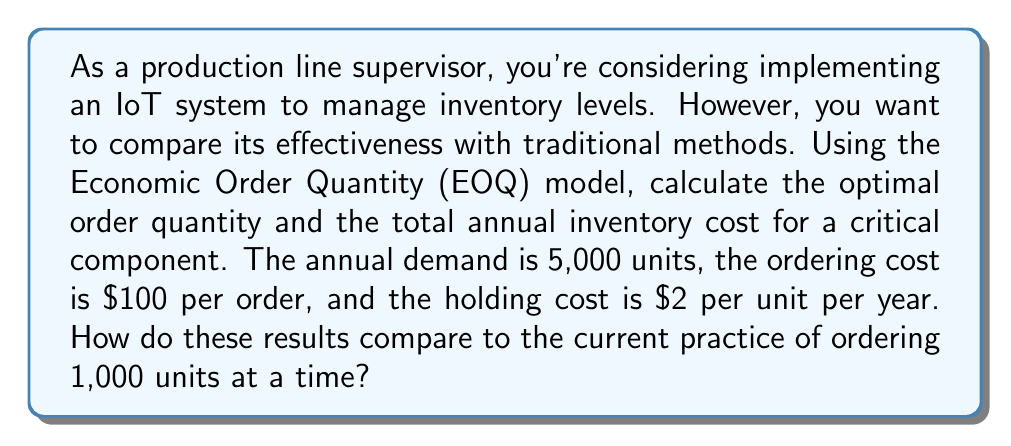Teach me how to tackle this problem. Let's approach this step-by-step using the EOQ model:

1. EOQ Formula:
   The Economic Order Quantity is given by:
   
   $$ Q^* = \sqrt{\frac{2DS}{H}} $$
   
   Where:
   $Q^*$ = Optimal order quantity
   $D$ = Annual demand
   $S$ = Ordering cost per order
   $H$ = Holding cost per unit per year

2. Given values:
   $D = 5,000$ units
   $S = \$100$ per order
   $H = \$2$ per unit per year

3. Calculate the EOQ:
   $$ Q^* = \sqrt{\frac{2 \cdot 5,000 \cdot 100}{2}} = \sqrt{500,000} = 707.11 $$
   
   Round to the nearest whole number: $Q^* = 707$ units

4. Calculate the number of orders per year:
   $$ \text{Number of orders} = \frac{D}{Q^*} = \frac{5,000}{707} \approx 7.07 \text{ orders} $$

5. Calculate total annual cost:
   Annual cost = Ordering cost + Holding cost
   
   $$ \text{Total Cost} = \frac{D}{Q^*} \cdot S + \frac{Q^*}{2} \cdot H $$
   $$ = \frac{5,000}{707} \cdot 100 + \frac{707}{2} \cdot 2 $$
   $$ = 707 + 707 = \$1,414 $$

6. Compare with current practice (1,000 units per order):
   Number of orders = $5,000 / 1,000 = 5$ orders per year
   
   $$ \text{Current Total Cost} = 5 \cdot 100 + \frac{1,000}{2} \cdot 2 = \$1,500 $$

The EOQ model suggests an optimal order quantity of 707 units, resulting in a total annual inventory cost of $1,414. This is $86 less than the current practice of ordering 1,000 units at a time, which costs $1,500 annually.
Answer: The optimal order quantity is 707 units, and the total annual inventory cost using the EOQ model is $1,414. This represents a savings of $86 per year compared to the current practice. 